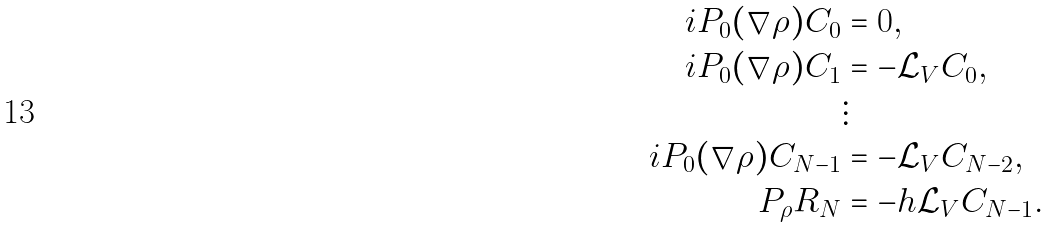Convert formula to latex. <formula><loc_0><loc_0><loc_500><loc_500>i P _ { 0 } ( \nabla \rho ) C _ { 0 } & = 0 , \\ i P _ { 0 } ( \nabla \rho ) C _ { 1 } & = - \mathcal { L } _ { V } C _ { 0 } , \\ & \vdots \\ i P _ { 0 } ( \nabla \rho ) C _ { N - 1 } & = - \mathcal { L } _ { V } C _ { N - 2 } , \\ P _ { \rho } R _ { N } & = - h \mathcal { L } _ { V } C _ { N - 1 } .</formula> 